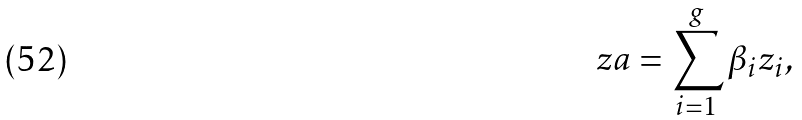<formula> <loc_0><loc_0><loc_500><loc_500>z a = \sum _ { i = 1 } ^ { g } \beta _ { i } z _ { i } ,</formula> 